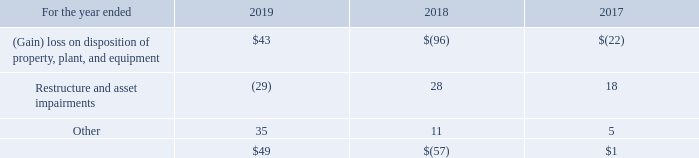Other Operating (Income) Expense, Net
Restructure and asset impairments primarily relate to our continued emphasis to centralize certain key functions. In addition, in 2019, we finalized the sale of our 200mm fabrication facility in Singapore and recognized restructure gains of $128 million. In 2017, we recognized net restructure gains of $15 million related to the sale of our Lexar assets; our assets associated with our 200mm fabrication facility in Singapore; and our 40% ownership interest in Tera Probe, Inc and assembly and test facility located in Akita, Japan.
In 2017, what is the net restructure gains of $15 million related to? The sale of our lexar assets; our assets associated with our 200mm fabrication facility in singapore; and our 40% ownership interest in tera probe, inc and assembly and test facility located in akita, japan. How much restructure gains did the company recognize in 2019? $128 million. What is the net other operating (income) expense for restructure and asset impairments in 2017?
Answer scale should be: million. 18. What is the percentage change of other operating (income) expenses for restructure and asset impairments between 2017 and 2018?
Answer scale should be: percent. (28-18)/18 
Answer: 55.56. What is the ratio of other operating expenses in 2019 to 2017? 35/5 
Answer: 7. What is the difference between total net other operating (income) expenses in 2017 and 2019?
Answer scale should be: million. $49-$1 
Answer: 48. 